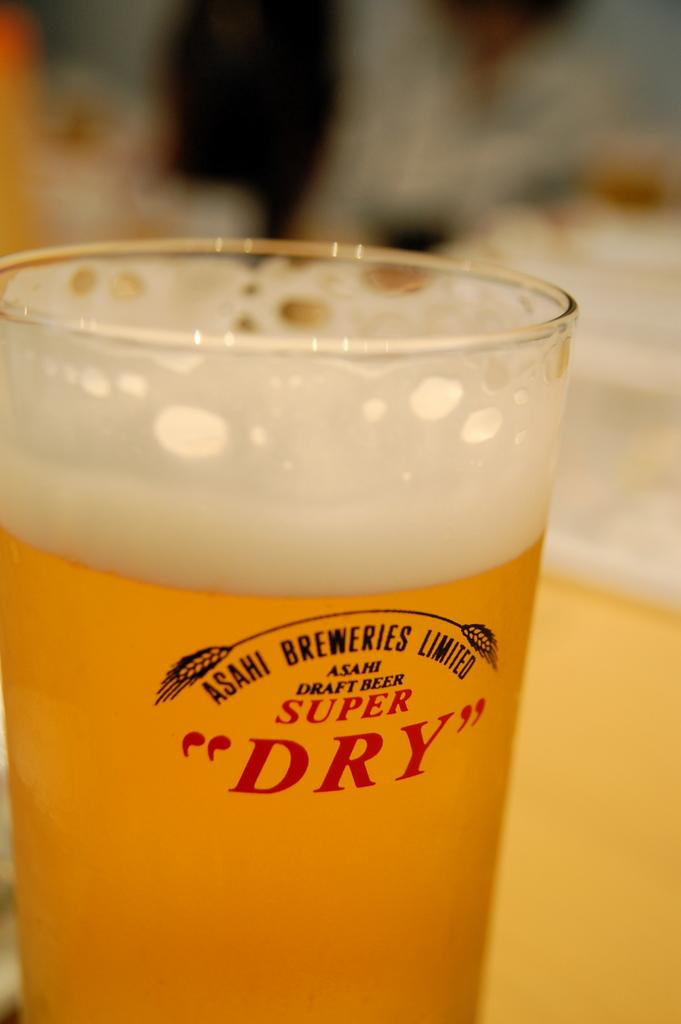What is inside the glass that is visible in the image? There is a tree inside the glass in the image. Where is the glass located in the image? The glass is on a table in the image. What is written on the glass? The name "Super Dry" is written on the glass. Can you describe the background of the image? The background of the image is blurred. What type of bird can be seen bursting out of the bag in the image? There is no bird or bag present in the image; it features a glass with a tree inside and a blurred background. 